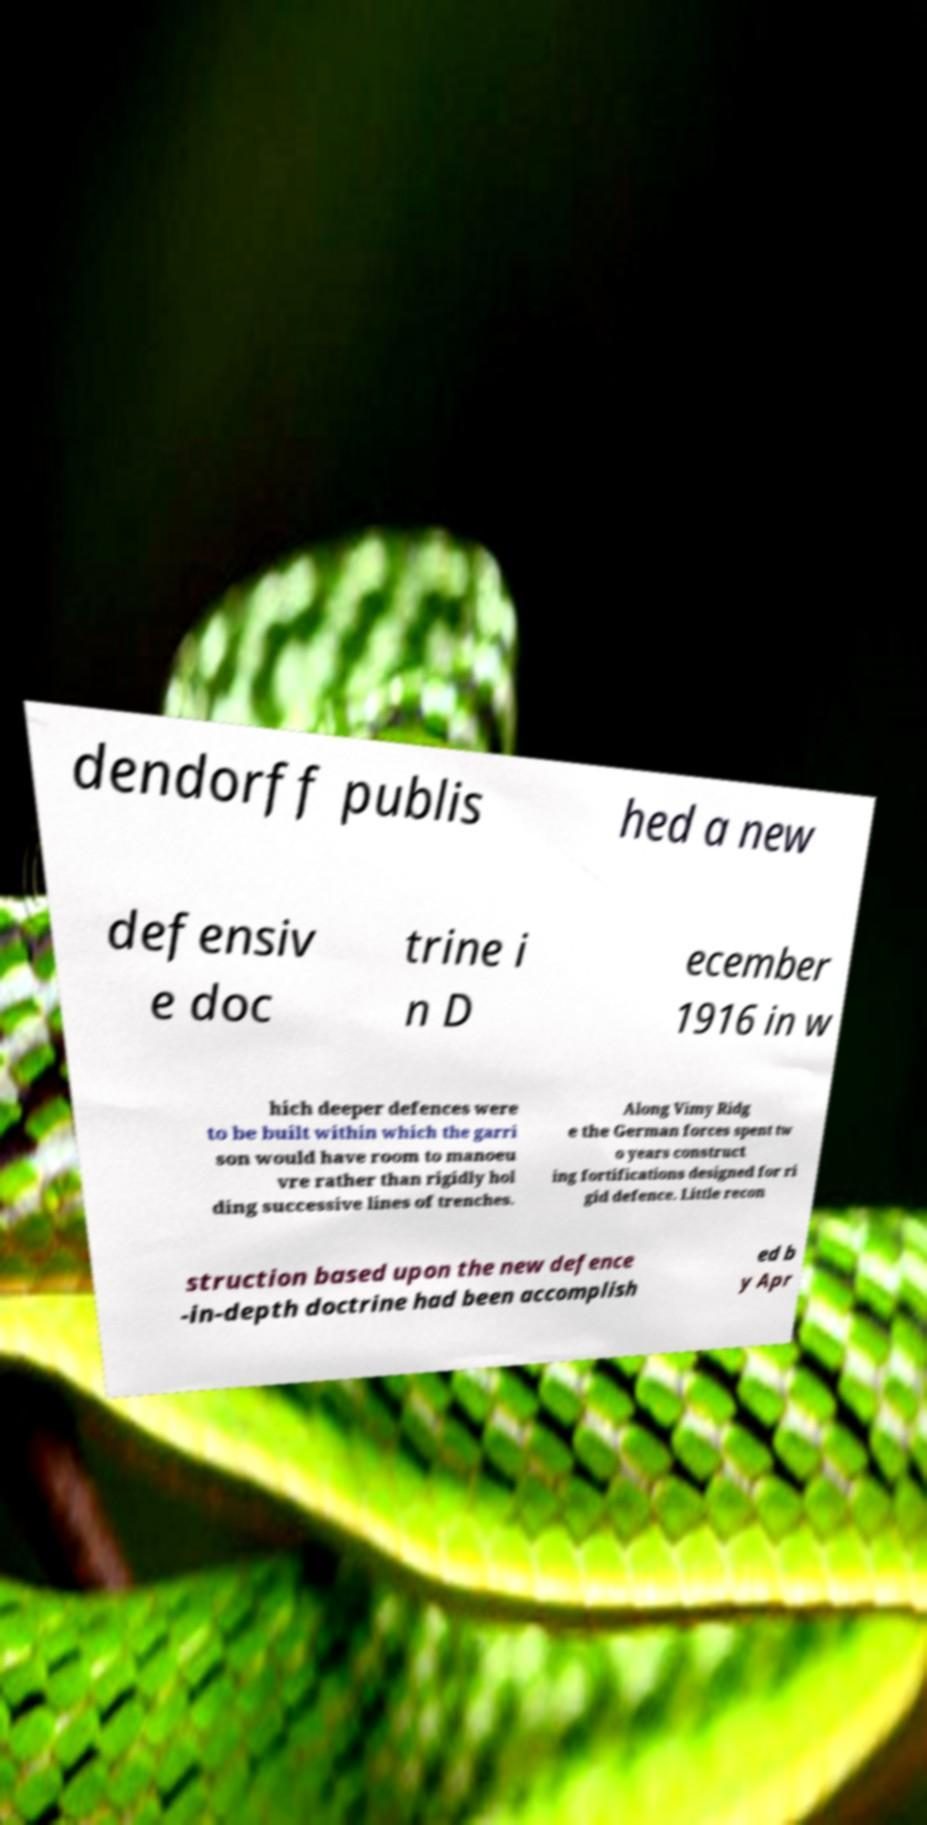Can you read and provide the text displayed in the image?This photo seems to have some interesting text. Can you extract and type it out for me? dendorff publis hed a new defensiv e doc trine i n D ecember 1916 in w hich deeper defences were to be built within which the garri son would have room to manoeu vre rather than rigidly hol ding successive lines of trenches. Along Vimy Ridg e the German forces spent tw o years construct ing fortifications designed for ri gid defence. Little recon struction based upon the new defence -in-depth doctrine had been accomplish ed b y Apr 